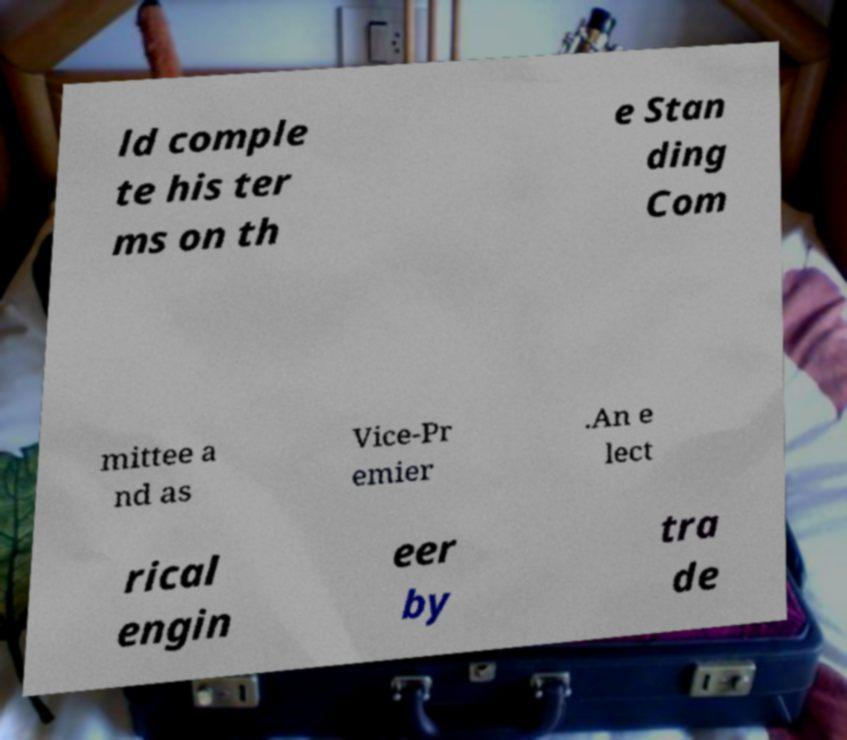Please read and relay the text visible in this image. What does it say? ld comple te his ter ms on th e Stan ding Com mittee a nd as Vice-Pr emier .An e lect rical engin eer by tra de 